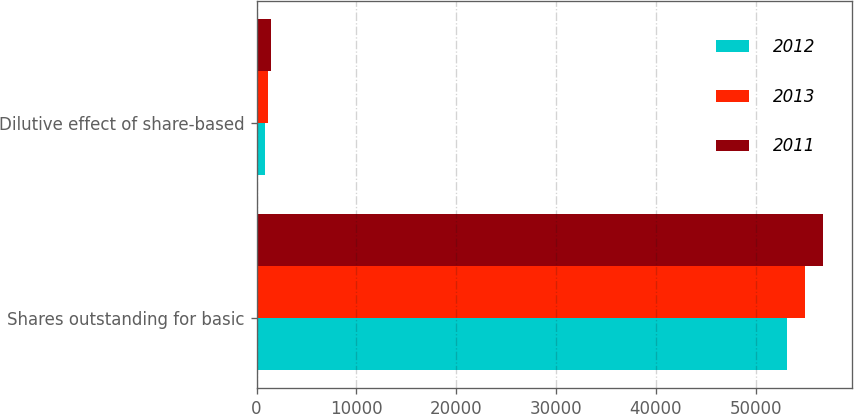Convert chart to OTSL. <chart><loc_0><loc_0><loc_500><loc_500><stacked_bar_chart><ecel><fcel>Shares outstanding for basic<fcel>Dilutive effect of share-based<nl><fcel>2012<fcel>53159<fcel>826<nl><fcel>2013<fcel>54985<fcel>1170<nl><fcel>2011<fcel>56790<fcel>1424<nl></chart> 